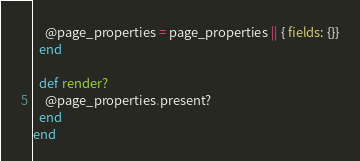<code> <loc_0><loc_0><loc_500><loc_500><_Ruby_>    @page_properties = page_properties || { fields: {}}
  end

  def render?
    @page_properties.present?
  end
end
</code> 